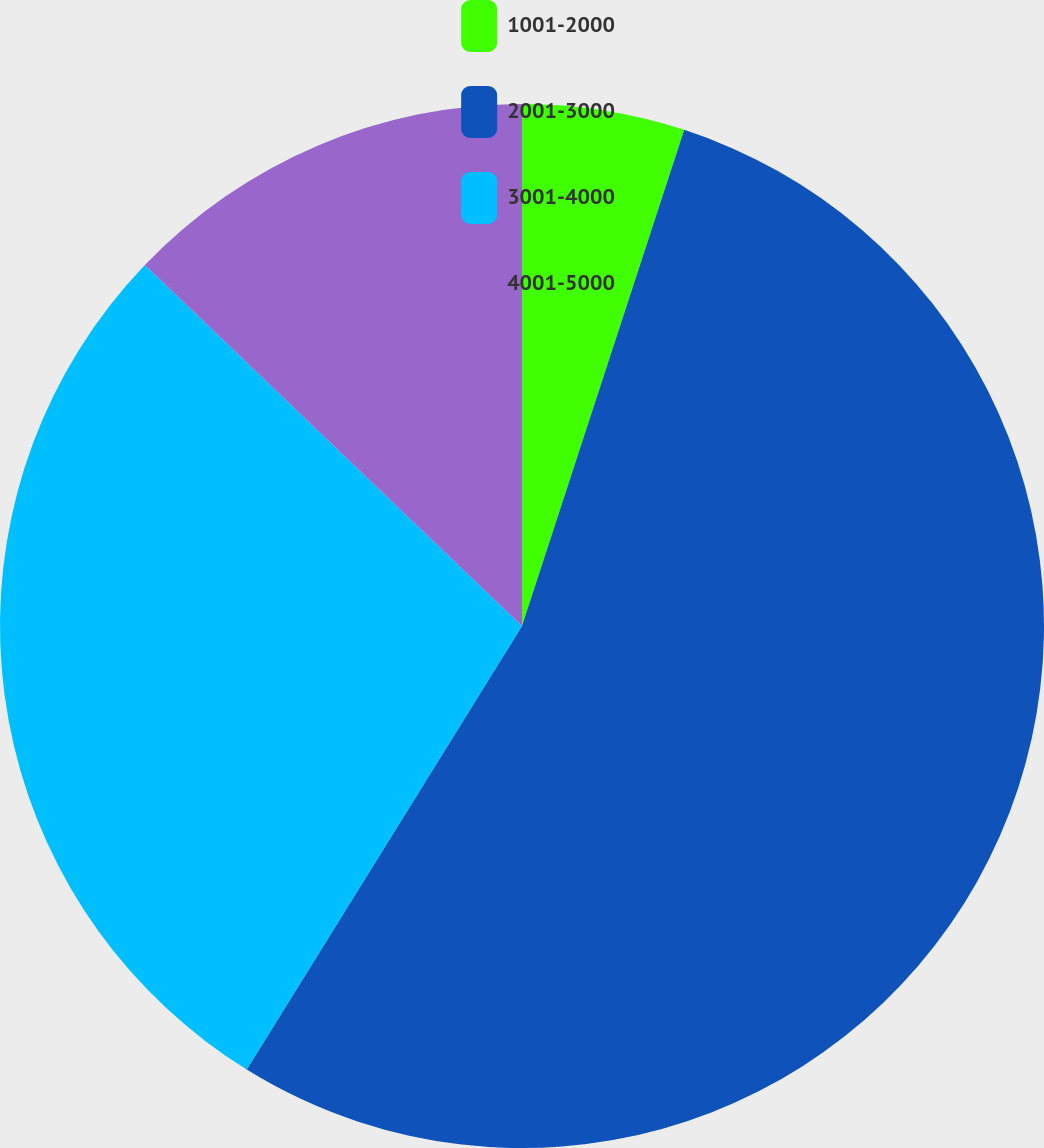Convert chart to OTSL. <chart><loc_0><loc_0><loc_500><loc_500><pie_chart><fcel>1001-2000<fcel>2001-3000<fcel>3001-4000<fcel>4001-5000<nl><fcel>5.03%<fcel>53.81%<fcel>28.31%<fcel>12.85%<nl></chart> 